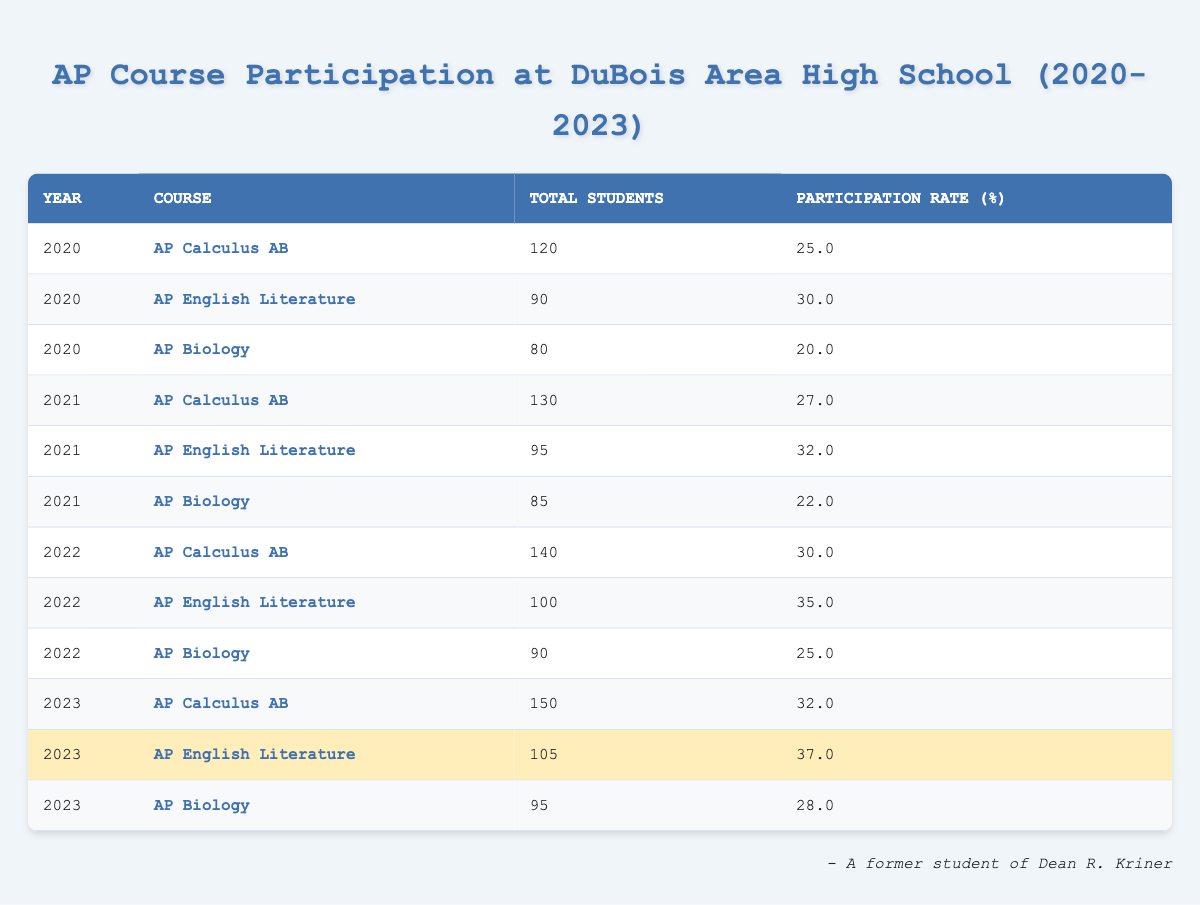What was the participation rate for AP Biology in 2021? Referring to the table, the participation rate for AP Biology in 2021 is listed as 22.0%.
Answer: 22.0% What was the total number of students participating in AP English Literature in 2022? According to the table, the total number of students for AP English Literature in 2022 is 100.
Answer: 100 Which year had the highest participation rate for AP Calculus AB? The participation rates for AP Calculus AB are: 2020 (25.0%), 2021 (27.0%), 2022 (30.0%), and 2023 (32.0%). The highest rate is in 2023 at 32.0%.
Answer: 2023 What is the average participation rate for AP English Literature over the years 2020 to 2023? The participation rates for AP English Literature are: 30.0% (2020), 32.0% (2021), 35.0% (2022), and 37.0% (2023). Summing them gives 30.0 + 32.0 + 35.0 + 37.0 = 134. Dividing by 4 gives an average of 134/4 = 33.5%.
Answer: 33.5% Did the participation rate for AP Biology increase from 2020 to 2023? The participation rates for AP Biology are: 20.0% (2020), 22.0% (2021), 25.0% (2022), and 28.0% (2023). Since each subsequent year shows an increase, the participation rate did increase.
Answer: Yes What is the difference in total students participating in AP Calculus AB from 2020 to 2023? The total students for AP Calculus AB are 120 (2020) and 150 (2023). The difference is calculated as 150 - 120 = 30.
Answer: 30 Which AP course had the lowest participation rate in 2020? The participation rates in 2020 are: AP Calculus AB (25.0%), AP English Literature (30.0%), and AP Biology (20.0%). AP Biology had the lowest at 20.0%.
Answer: AP Biology How much did the participation rate for AP English Literature increase from 2020 to 2023? The participation rates are 30.0% (2020) and 37.0% (2023). The increase is calculated as 37.0% - 30.0% = 7.0%.
Answer: 7.0% In which year did AP Biology have the highest total number of students? The total number of students for AP Biology over the years are: 80 (2020), 85 (2021), 90 (2022), and 95 (2023). The highest is 95 in 2023.
Answer: 2023 